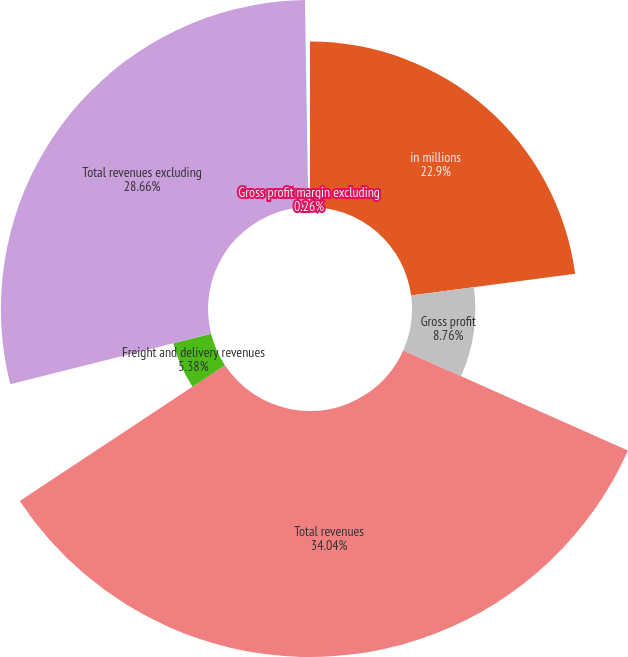Convert chart to OTSL. <chart><loc_0><loc_0><loc_500><loc_500><pie_chart><fcel>in millions<fcel>Gross profit<fcel>Total revenues<fcel>Freight and delivery revenues<fcel>Total revenues excluding<fcel>Gross profit margin excluding<nl><fcel>22.9%<fcel>8.76%<fcel>34.04%<fcel>5.38%<fcel>28.66%<fcel>0.26%<nl></chart> 